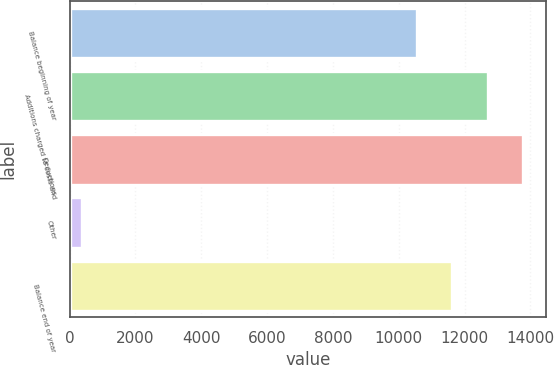Convert chart to OTSL. <chart><loc_0><loc_0><loc_500><loc_500><bar_chart><fcel>Balance beginning of year<fcel>Additions charged to costs and<fcel>Deductions<fcel>Other<fcel>Balance end of year<nl><fcel>10548<fcel>12704.2<fcel>13782.3<fcel>389<fcel>11626.1<nl></chart> 